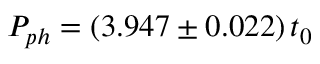<formula> <loc_0><loc_0><loc_500><loc_500>P _ { p h } = ( 3 . 9 4 7 \pm 0 . 0 2 2 ) \, t _ { 0 }</formula> 